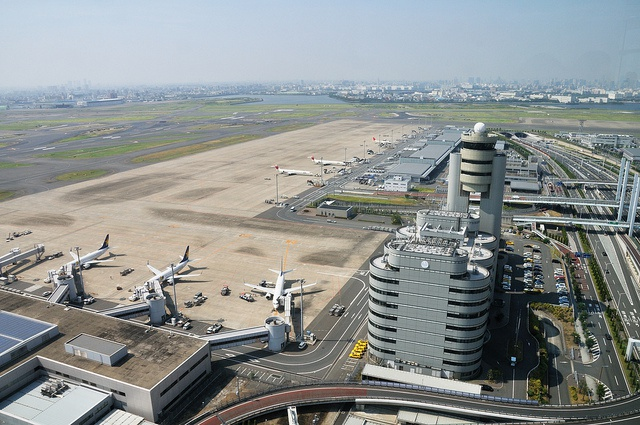Describe the objects in this image and their specific colors. I can see car in lightblue, gray, black, and darkgray tones, airplane in lightblue, white, darkgray, gray, and lightgray tones, airplane in lightblue, lightgray, darkgray, gray, and tan tones, airplane in lightblue, lightgray, darkgray, tan, and gray tones, and airplane in lightblue, lightgray, and darkgray tones in this image. 